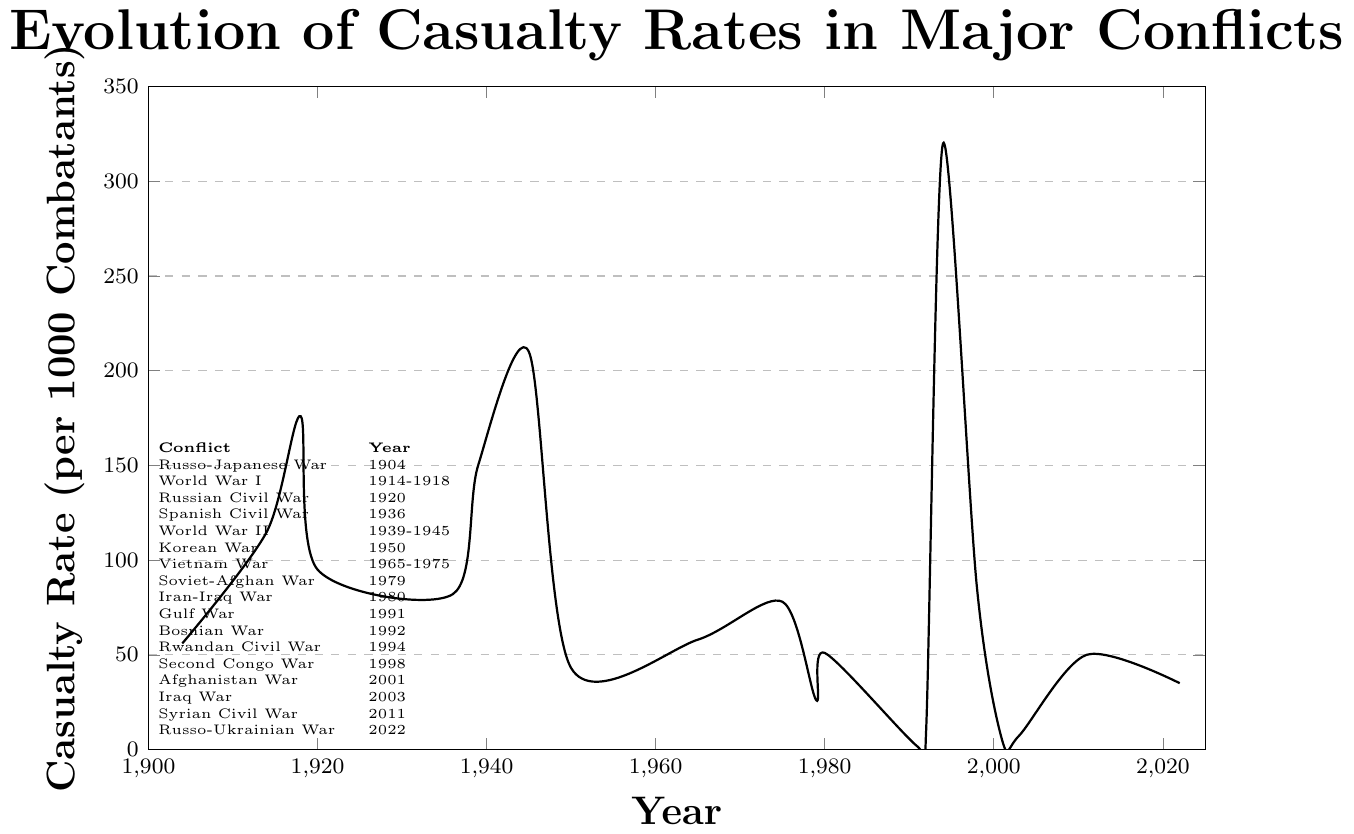Which conflict has the highest casualty rate in the 20th and 21st centuries? The plot shows the casualty rates of various conflicts. The highest point on the y-axis, which represents the casualty rate per 1000 combatants, occurs in 1994 during the Rwandan Civil War.
Answer: Rwandan Civil War By how much did the casualty rate increase from the start to the end of World War II? World War II is represented in the years 1939 and 1945. The casualty rate increased from 150 (1939) to 210 (1945). The difference is 210 - 150.
Answer: 60 Which wars have a casualty rate below 10 per 1000 combatants? The data points below the 10 mark on the y-axis are in the Gulf War (1.5), Bosnian War (10), the Afghanistan War (4.8), and the Iraq War (7.3).
Answer: Gulf War, Bosnian War, Afghanistan War, Iraq War How does the casualty rate in the Korean War compare to that in the Vietnam War during its peak? The Korean War data (1950) shows a casualty rate of 43. The highest data point for the Vietnam War (1975) is 78.
Answer: Vietnam War's peak rate is higher What's the average casualty rate of the conflicts in the 20th century? Conflicts in the 20th century include those from 1904 to 1998. The rates are: 56, 115, 176, 95, 82, 150, 210, 43, 58, 78, 26, 51, 1.5, 10, 320, 86. The sum of these rates is 1557.5. There are 16 conflicts. The average is 1557.5 / 16.
Answer: 97.34 Which conflict had the lowest casualty rate, and what was it? Among the plotted data points, the lowest casualty rate is evident for the Gulf War, which is 1.5 per 1000 combatants.
Answer: Gulf War, 1.5 How many conflicts have a casualty rate greater than 100 per 1000 combatants? The data points above 100 on the y-axis are in World War I (1914, 1918), World War II (1939, 1945), and Rwandan Civil War (1994). This results in 4 conflicts.
Answer: 4 Comparing the Russo-Japanese War (1904) and the Soviet-Afghan War (1979), which had a higher casualty rate? By how much? The Russo-Japanese War (1904) has a casualty rate of 56, and the Soviet-Afghan War (1979) has a rate of 26. The difference is 56 - 26.
Answer: Russo-Japanese War, 30 What's the difference in casualty rates between the beginning and the end of the Vietnam War? The Vietnam War data points for 1965 and 1975 show rates of 58 and 78, respectively. The difference is 78 - 58.
Answer: 20 